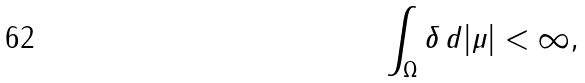<formula> <loc_0><loc_0><loc_500><loc_500>\int _ { \Omega } \delta \, d | \mu | < \infty ,</formula> 